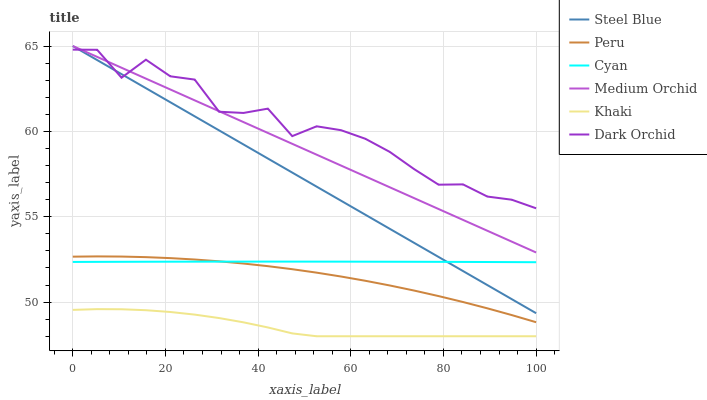Does Khaki have the minimum area under the curve?
Answer yes or no. Yes. Does Dark Orchid have the maximum area under the curve?
Answer yes or no. Yes. Does Medium Orchid have the minimum area under the curve?
Answer yes or no. No. Does Medium Orchid have the maximum area under the curve?
Answer yes or no. No. Is Medium Orchid the smoothest?
Answer yes or no. Yes. Is Dark Orchid the roughest?
Answer yes or no. Yes. Is Steel Blue the smoothest?
Answer yes or no. No. Is Steel Blue the roughest?
Answer yes or no. No. Does Khaki have the lowest value?
Answer yes or no. Yes. Does Medium Orchid have the lowest value?
Answer yes or no. No. Does Steel Blue have the highest value?
Answer yes or no. Yes. Does Dark Orchid have the highest value?
Answer yes or no. No. Is Peru less than Medium Orchid?
Answer yes or no. Yes. Is Cyan greater than Khaki?
Answer yes or no. Yes. Does Steel Blue intersect Medium Orchid?
Answer yes or no. Yes. Is Steel Blue less than Medium Orchid?
Answer yes or no. No. Is Steel Blue greater than Medium Orchid?
Answer yes or no. No. Does Peru intersect Medium Orchid?
Answer yes or no. No. 